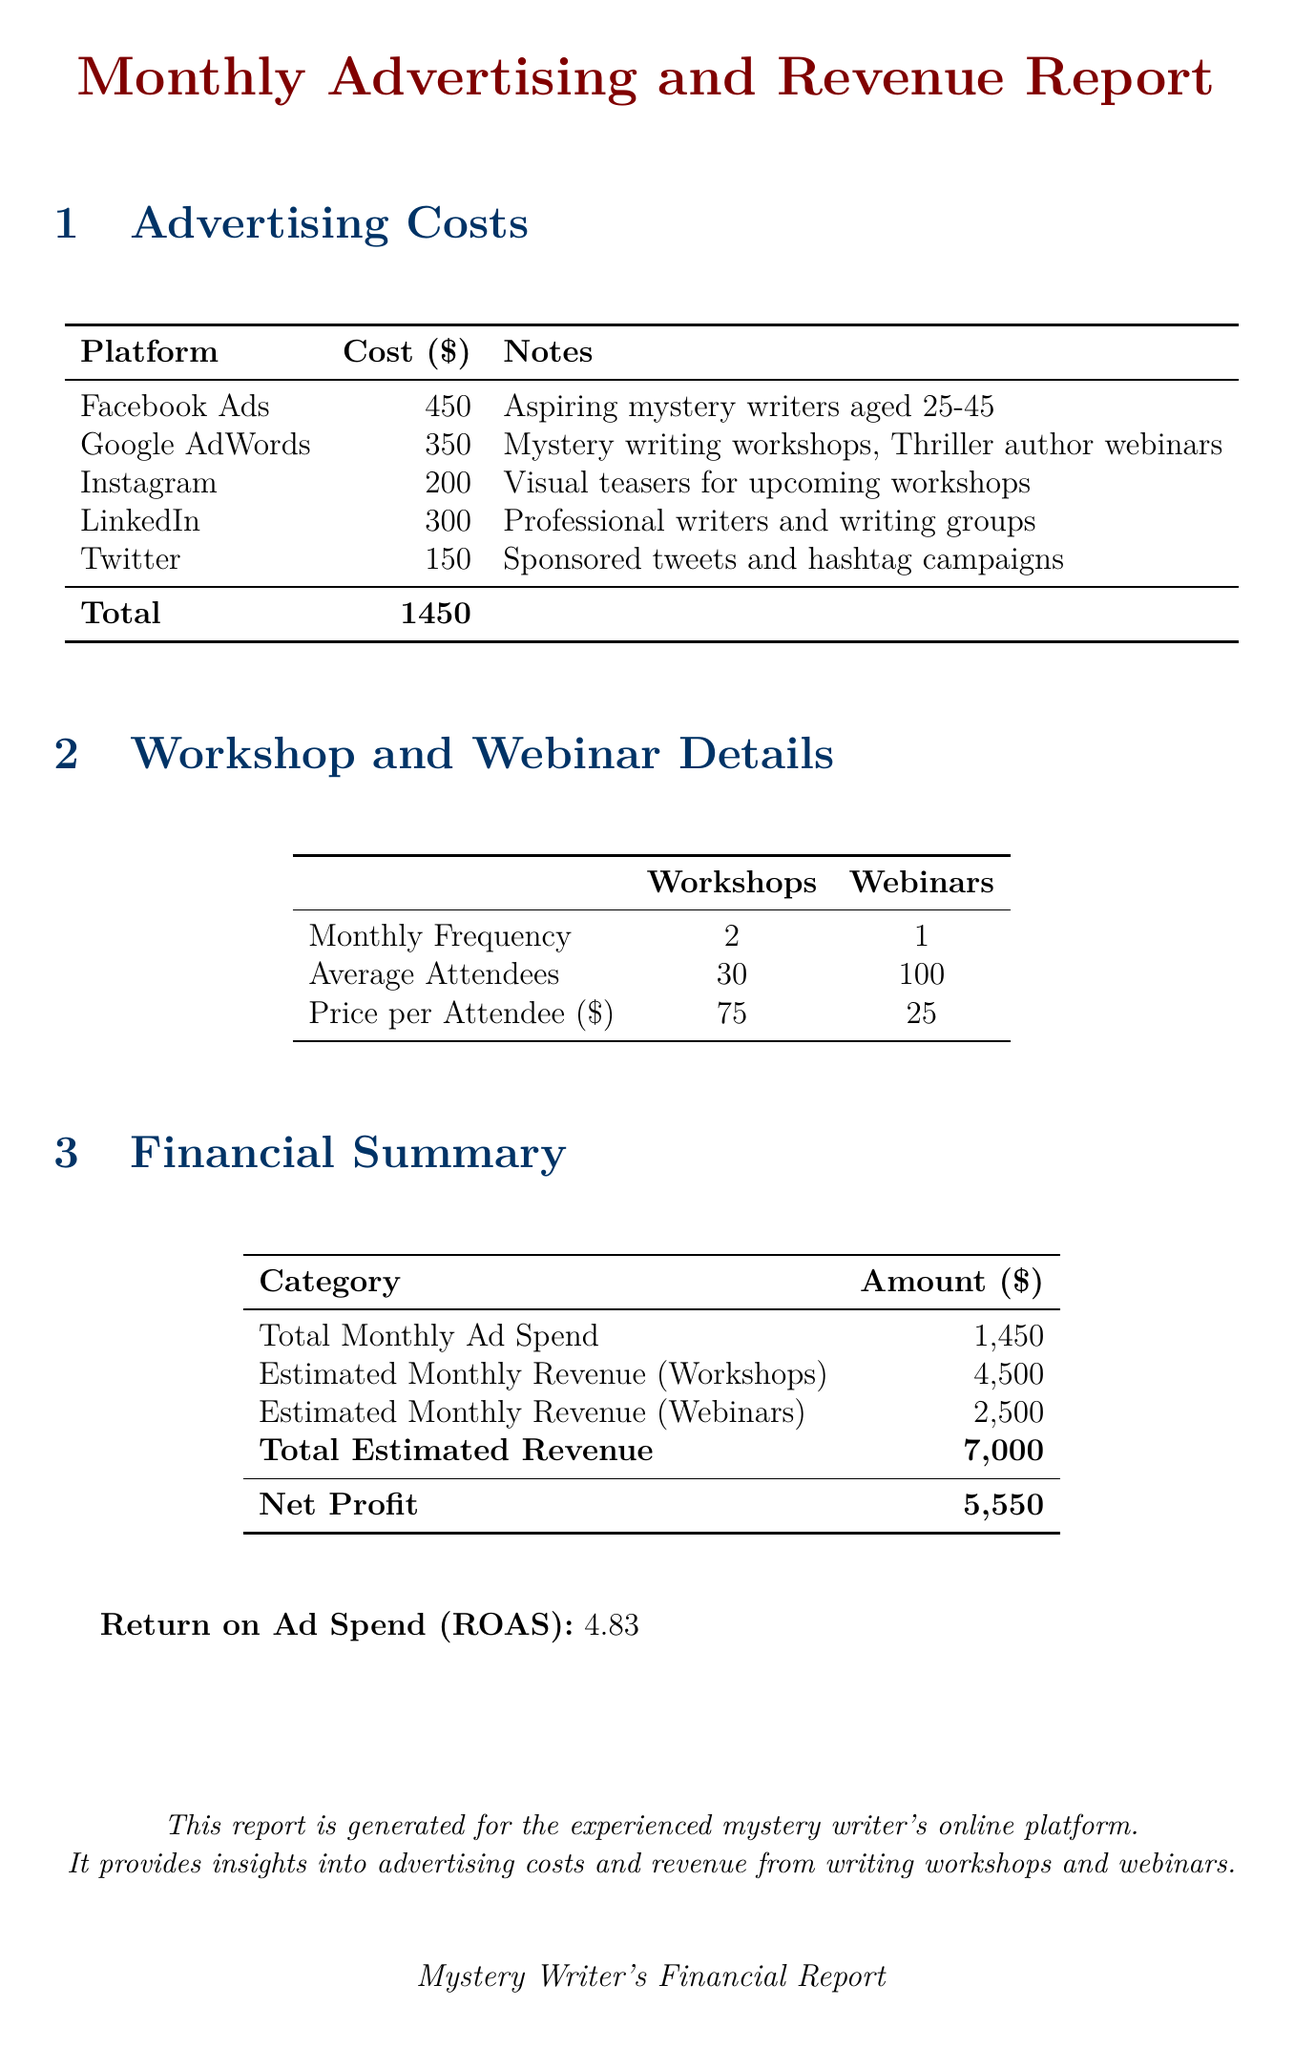what is the total monthly advertising spend? The total monthly advertising spend is provided in the financial summary section of the document.
Answer: 1450 how much does a webinar attendee pay? The price per webinar attendee is mentioned in the workshop and webinar details section.
Answer: 25 what is the cost of Google AdWords? The cost for Google AdWords is listed in the advertising costs table.
Answer: 350 how many monthly workshops are conducted? The number of monthly workshops is specified in the workshop and webinar details section.
Answer: 2 what is the estimated monthly revenue from workshops? The estimated revenue from workshops is detailed in the financial summary section.
Answer: 4500 how many average attendees are there for webinars? The average number of attendees for webinars is given in the workshop and webinar details section.
Answer: 100 what is the return on ad spend? The return on ad spend is specifically stated at the end of the financial summary.
Answer: 4.83 which platform has the highest advertising cost? The platform with the highest advertising cost can be identified from the advertising costs table.
Answer: Facebook Ads what is the target audience for Facebook Ads? The target audience for Facebook Ads is indicated in the advertising costs table.
Answer: Aspiring mystery writers aged 25-45 